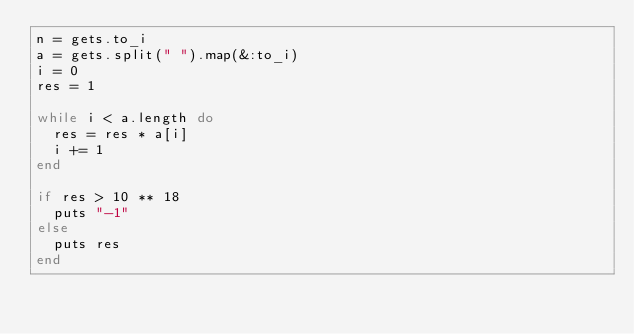Convert code to text. <code><loc_0><loc_0><loc_500><loc_500><_Ruby_>n = gets.to_i
a = gets.split(" ").map(&:to_i)
i = 0
res = 1
 
while i < a.length do
  res = res * a[i]
  i += 1
end
 
if res > 10 ** 18
  puts "-1"
else
  puts res
end</code> 